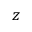<formula> <loc_0><loc_0><loc_500><loc_500>z</formula> 